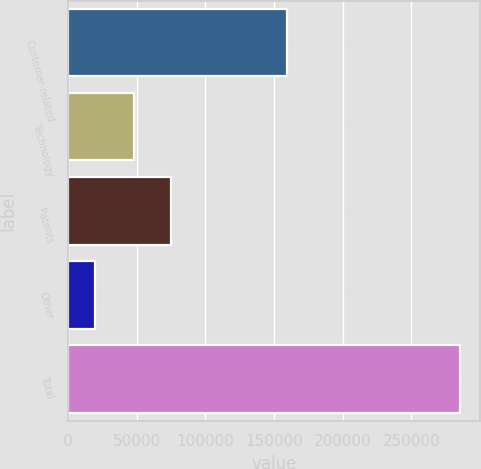<chart> <loc_0><loc_0><loc_500><loc_500><bar_chart><fcel>Customer-related<fcel>Technology<fcel>Patents<fcel>Other<fcel>Total<nl><fcel>159774<fcel>48270<fcel>74869.5<fcel>19680<fcel>285675<nl></chart> 